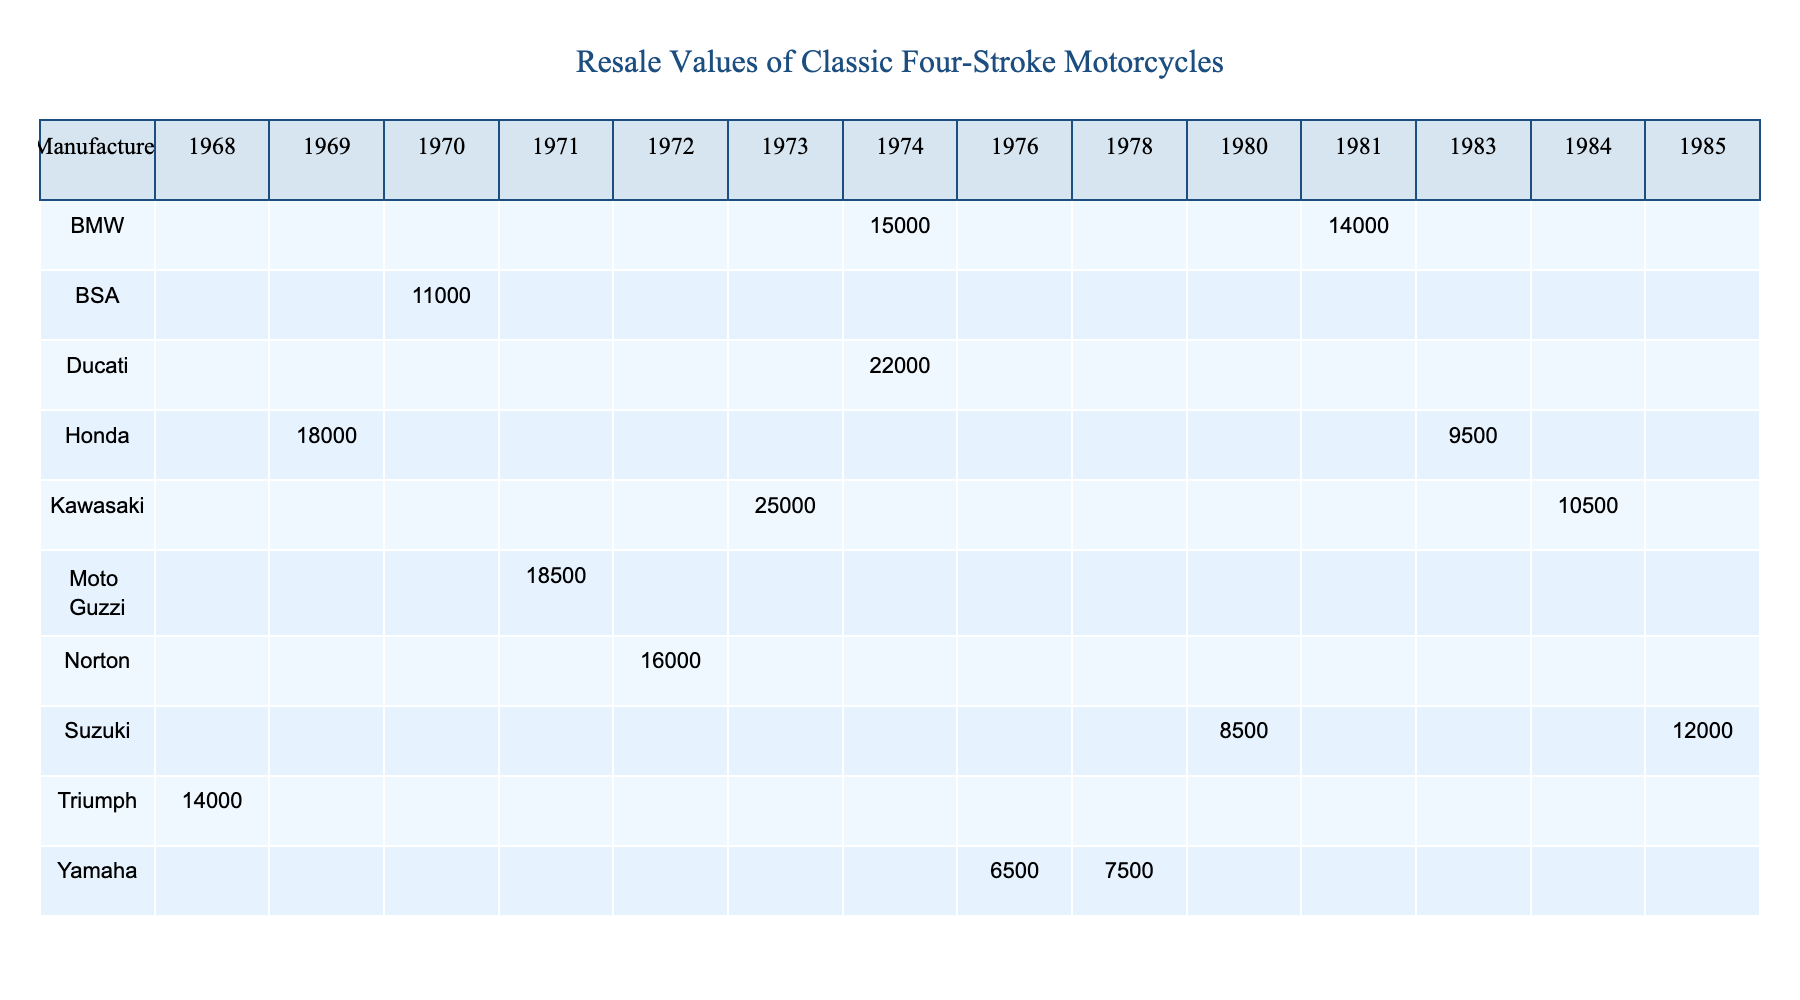What is the resale value of the Kawasaki Z1? The table lists the resale value for the Kawasaki Z1 under the year 1973, which is $25,000.
Answer: $25,000 Which motorcycle has the highest resale value? Scanning through the resale values in the table, the Kawasaki Z1 from 1973 has the highest resale value of $25,000.
Answer: Kawasaki Z1 What is the original MSRP of the Honda CB750? The original MSRP of the Honda CB750, listed in the table under the year 1969, is $1,495.
Answer: $1,495 Is the resale value of the BMW R90S greater than $15,000? Checking the resale value of the BMW R90S from 1974, which is $15,000, we see that it is not greater than $15,000.
Answer: No How much more is the resale value of the Ducati 750 GT than the BSA A65 Lightning? The resale value of the Ducati 750 GT is $22,000, while the BSA A65 Lightning is $11,000. The difference is $22,000 - $11,000 = $11,000.
Answer: $11,000 What is the average resale value for all the motorcycles listed in the table? To calculate the average, we sum all resale values: $18,000 + $25,000 + $15,000 + $12,000 + $7,500 + $14,000 + $22,000 + $18,500 + $16,000 + $11,000 + $9,500 + $10,500 + $14,000 + $8,500 + $6,500 = $150,000. There are 15 motorcycles, so the average is $150,000 / 15 = $10,000.
Answer: $10,000 Which manufacturer has the most models listed in the table? Counting the entries for each manufacturer, Honda, Kawasaki, and BMW each appear twice, while others appear once, so the manufacturers with most models are Honda and Kawasaki and BMW.
Answer: Honda, Kawasaki, BMW What is the difference in resale value between the oldest and the newest motorcycle in the table? The oldest motorcycle is the Triumph Bonneville T120 from 1968 with a resale value of $14,000, and the newest motorcycle is the Suzuki GSX-R750 from 1985 with a resale value of $12,000. The difference is $14,000 - $12,000 = $2,000.
Answer: $2,000 List any motorcycles that have a resale value of less than $10,000. Looking through the table, the Yamaha SR500, Honda CB1100F, Kawasaki GPz900R, Suzuki GS1000G, and Yamaha XS650 have resale values of $7,500, $9,500, $10,500, $8,500, and $6,500, respectively, with the first three being less than $10,000.
Answer: Yamaha SR500, Honda CB1100F, Suzuki GS1000G, Yamaha XS650 What is the original MSRP of the motorcycle with the highest resale value? The motorcycle with the highest resale value is the Kawasaki Z1, which has an original MSRP of $1,895.
Answer: $1,895 